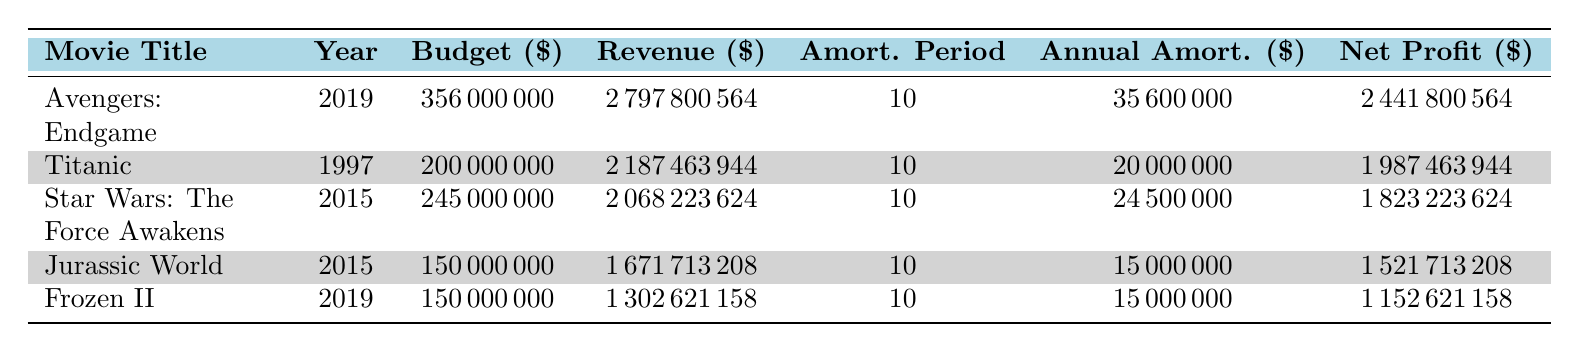What is the production budget of "Avengers: Endgame"? The table shows the budget for each movie in the third column. For "Avengers: Endgame," the production budget is listed as 356000000.
Answer: 356000000 Which movie had the highest net profit? The net profit is located in the last column of the table. Comparing the net profits, "Avengers: Endgame" has the highest at 2441800564.
Answer: Avengers: Endgame What is the total gross revenue for "Titanic" and "Jurassic World"? To find the total gross revenue, we add the revenue of "Titanic" (2187463944) and "Jurassic World" (1671713208). The calculation is 2187463944 + 1671713208 = 3859176152.
Answer: 3859176152 Does "Frozen II" have a production budget lower than 200 million dollars? The production budget for "Frozen II" is listed as 150000000 in the second column, which is indeed lower than 200 million dollars.
Answer: Yes What is the average annual amortization for all the movies listed in the table? To calculate the average, we sum the annual amortizations: 35600000 + 20000000 + 24500000 + 15000000 + 15000000 = 110500000. Then divide by the number of movies (5), so 110500000 / 5 = 22100000.
Answer: 22100000 How many movies have a gross revenue exceeding 2 billion dollars? By inspecting the gross revenue figures, "Avengers: Endgame" and "Titanic" both exceed 2 billion dollars. Thus, there are 2 movies in total.
Answer: 2 What is the difference in net profit between "Star Wars: The Force Awakens" and "Frozen II"? First, find the net profit of each movie: "Star Wars: The Force Awakens" has 1823223624, and "Frozen II" has 1152621158. The difference is 1823223624 - 1152621158 = 670596466.
Answer: 670596466 Is the amortization period the same for all listed movies? Yes, the amortization period for each movie listed in the table is consistently 10 years.
Answer: Yes Which movie released in 2015 has the lowest production budget? By comparing the production budgets for the movies released in 2015, "Jurassic World" has the lowest budget at 150000000, compared to "Star Wars: The Force Awakens" which is 245000000.
Answer: Jurassic World 